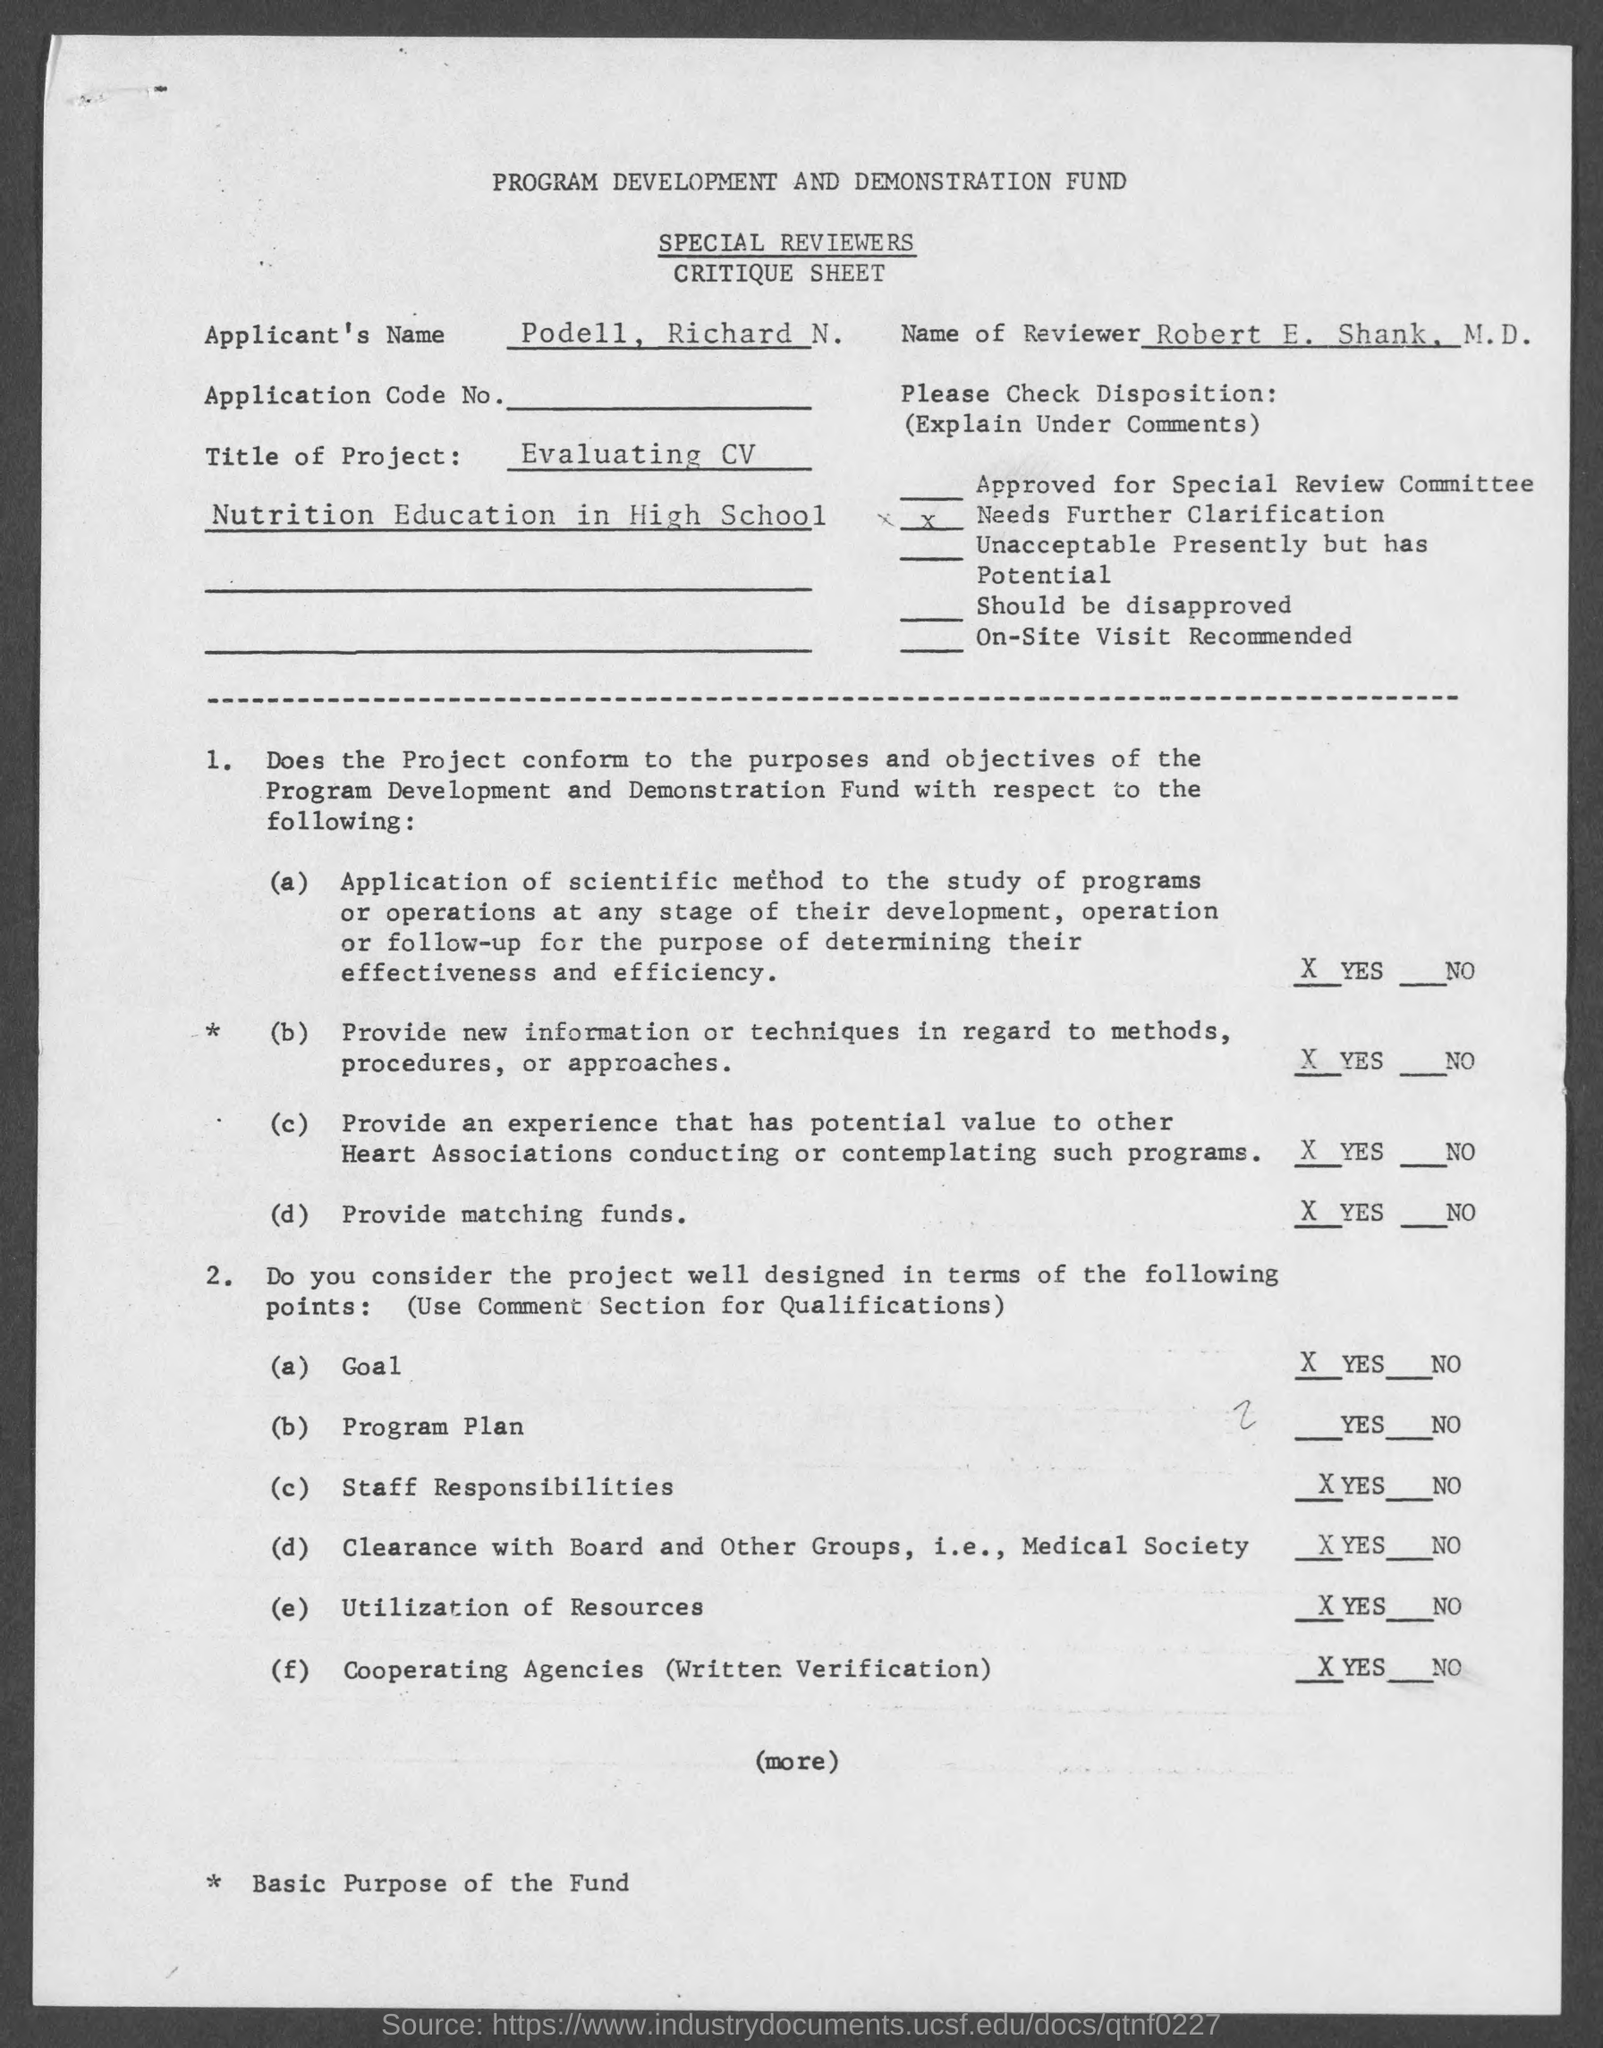What is the applicant's name mentioned in the given critique sheet ?
Your response must be concise. PODELL, RICHARD N. 